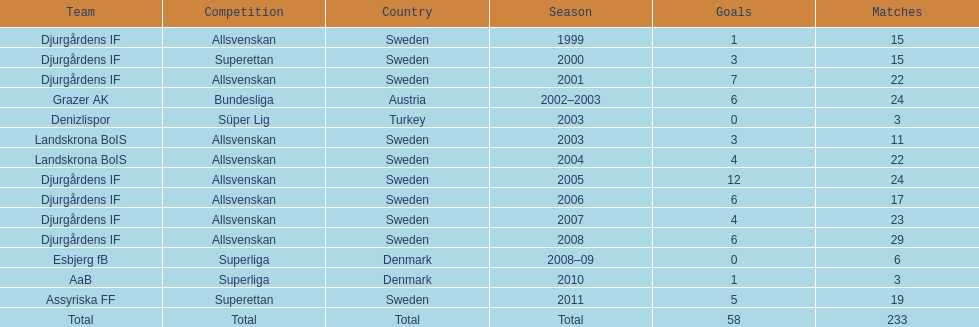What is the total number of matches? 233. 